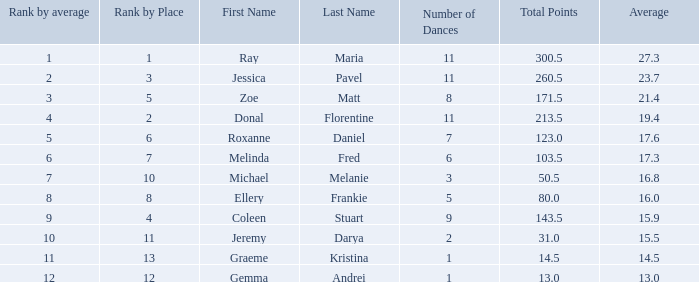What place would you be in if your rank by average is less than 2.0? 1.0. 